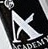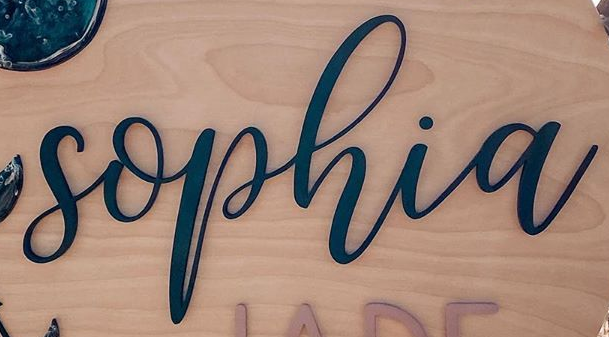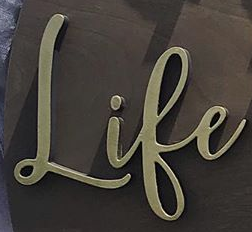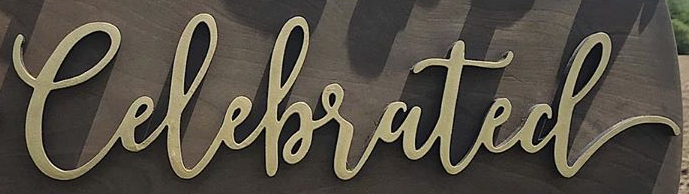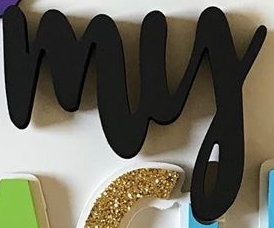What words are shown in these images in order, separated by a semicolon? A; sophia; Life; Celebrated; my 